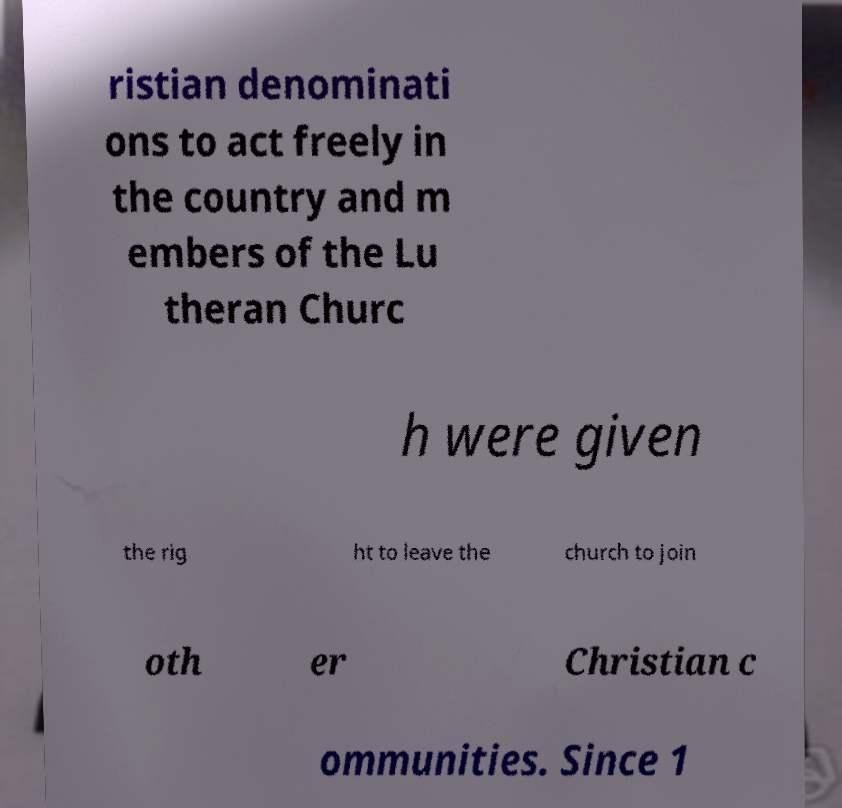Please identify and transcribe the text found in this image. ristian denominati ons to act freely in the country and m embers of the Lu theran Churc h were given the rig ht to leave the church to join oth er Christian c ommunities. Since 1 